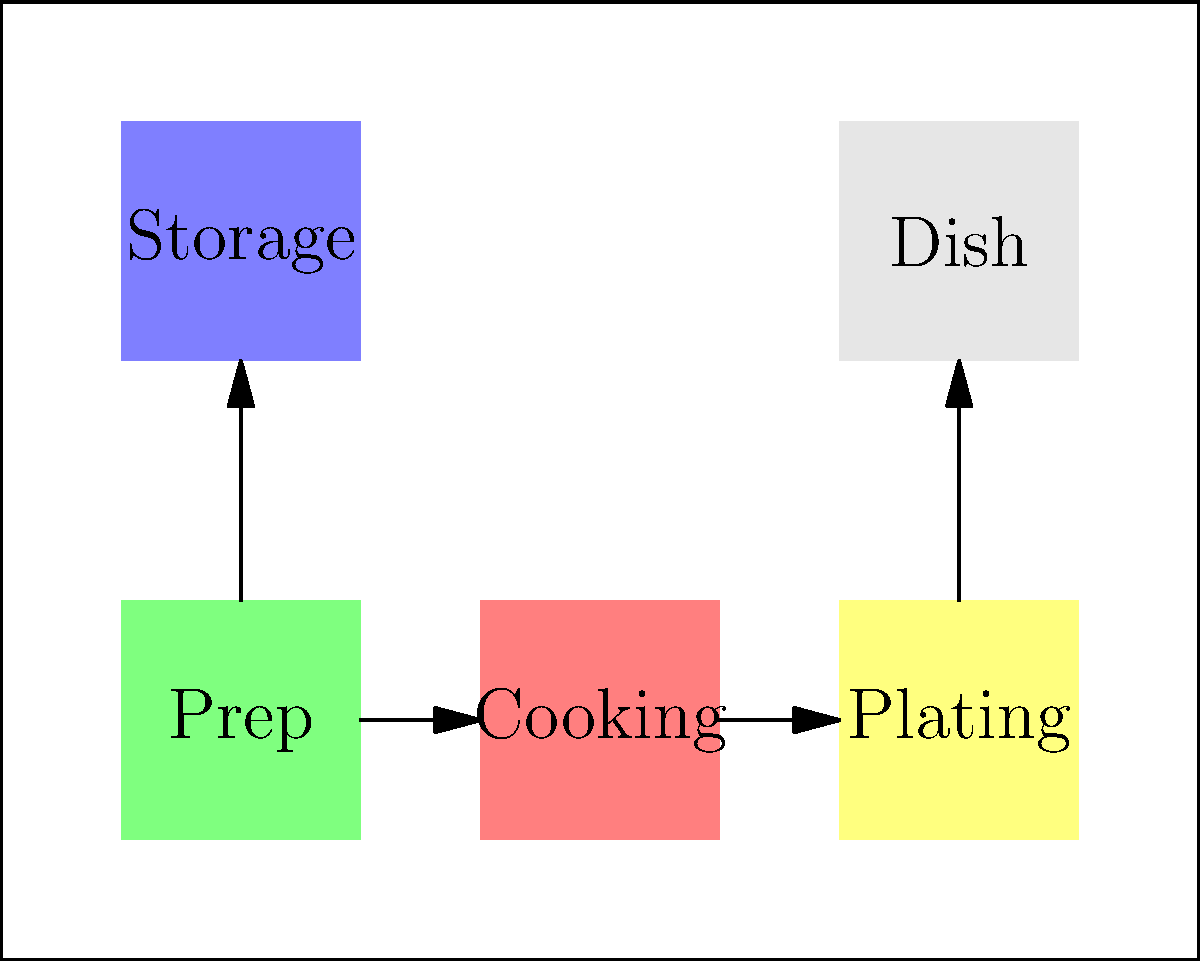In the given kitchen layout, which arrangement of stations would create the most efficient workflow for a busy restaurant kitchen? To determine the most efficient workflow in a kitchen layout, we need to consider the following steps:

1. Identify the main stations:
   - Prep area (green)
   - Cooking area (red)
   - Plating area (yellow)
   - Storage area (blue)
   - Dish washing area (gray)

2. Analyze the current layout:
   - The stations are arranged in a linear fashion from left to right: prep, cooking, and plating.
   - Storage is located above the prep area.
   - Dish washing is located above the plating area.

3. Evaluate the workflow:
   - The linear arrangement of prep, cooking, and plating allows for a smooth flow of ingredients and dishes.
   - The storage area is close to the prep area, minimizing movement for retrieving ingredients.
   - The dish washing area is near the plating area, allowing for easy return of clean dishes.

4. Consider the principles of kitchen efficiency:
   - Minimize cross-traffic and backtracking
   - Keep related tasks close together
   - Ensure a logical flow from ingredient storage to final plating

5. Assess the current layout against these principles:
   - The layout minimizes cross-traffic by keeping the main workflow linear.
   - Related tasks (storage-prep, plating-dish washing) are kept close together.
   - There is a logical flow from storage to prep to cooking to plating.

Given these considerations, the current layout as shown in the diagram represents an efficient workflow for a busy restaurant kitchen. It allows for a smooth progression of tasks from ingredient storage and preparation to cooking, plating, and dish washing, while minimizing unnecessary movement and potential bottlenecks.
Answer: The current layout 